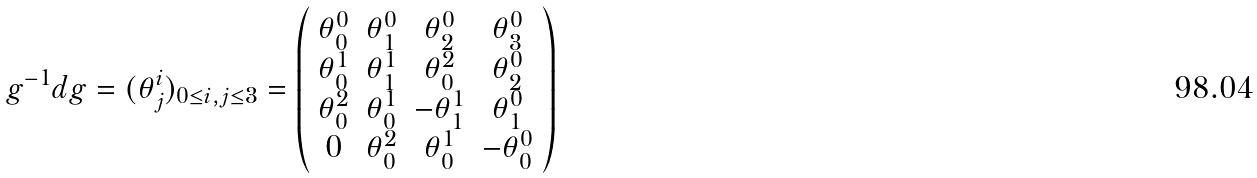<formula> <loc_0><loc_0><loc_500><loc_500>g ^ { - 1 } d g = ( \theta ^ { i } _ { j } ) _ { 0 \leq i , j \leq 3 } = \left ( \begin{array} { c c c c } \theta ^ { 0 } _ { 0 } & \theta ^ { 0 } _ { 1 } & \theta ^ { 0 } _ { 2 } & \theta ^ { 0 } _ { 3 } \\ \theta ^ { 1 } _ { 0 } & \theta ^ { 1 } _ { 1 } & \theta ^ { 2 } _ { 0 } & \theta ^ { 0 } _ { 2 } \\ \theta ^ { 2 } _ { 0 } & \theta ^ { 1 } _ { 0 } & - \theta ^ { 1 } _ { 1 } & \theta ^ { 0 } _ { 1 } \\ 0 & \theta ^ { 2 } _ { 0 } & \theta ^ { 1 } _ { 0 } & - \theta ^ { 0 } _ { 0 } \\ \end{array} \right )</formula> 